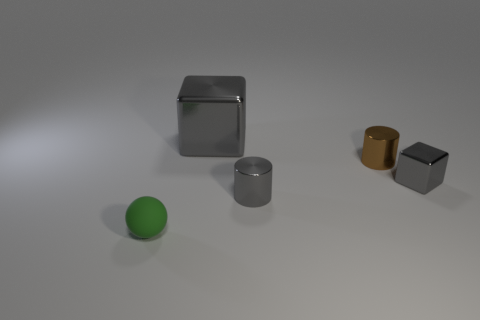Add 2 gray metal objects. How many objects exist? 7 Subtract all cubes. How many objects are left? 3 Add 4 cyan spheres. How many cyan spheres exist? 4 Subtract 0 red cylinders. How many objects are left? 5 Subtract all tiny gray metallic cubes. Subtract all small green balls. How many objects are left? 3 Add 3 brown cylinders. How many brown cylinders are left? 4 